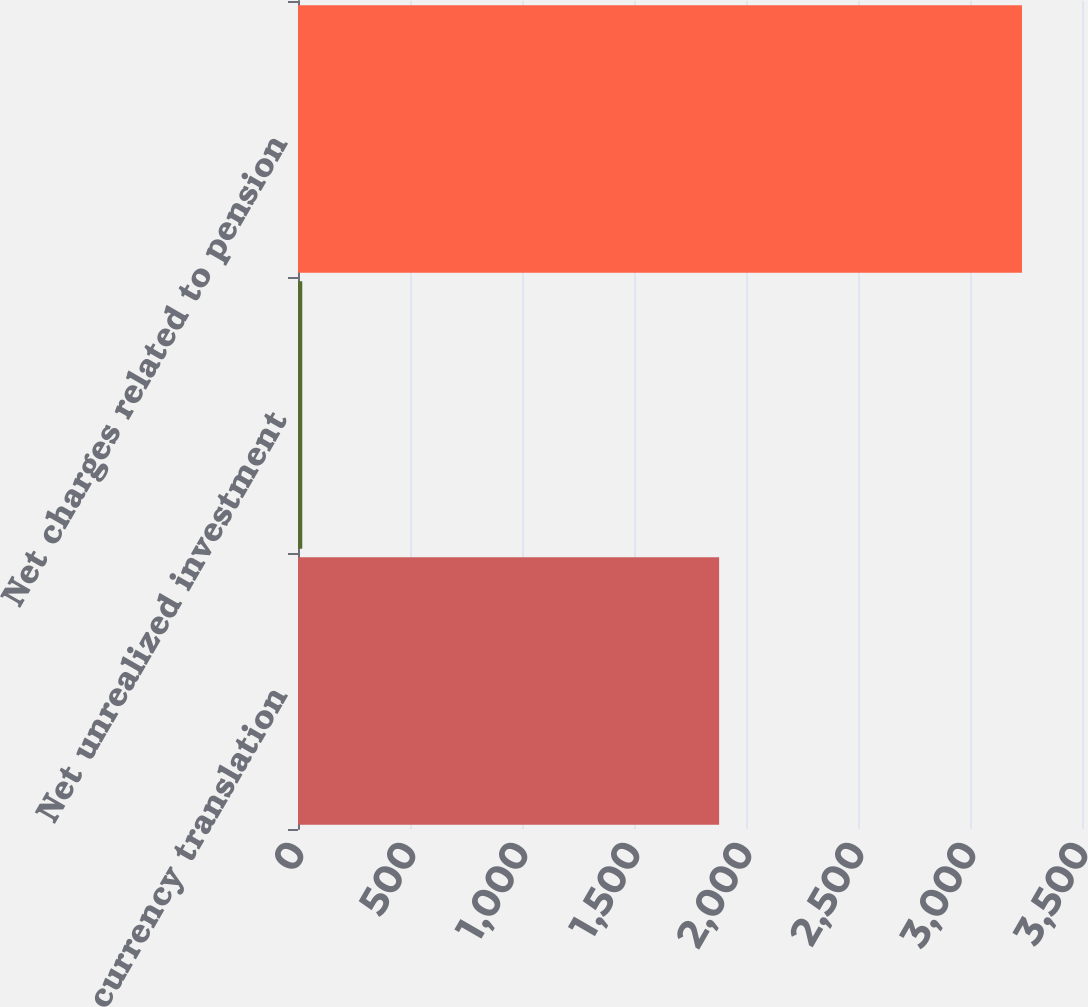Convert chart. <chart><loc_0><loc_0><loc_500><loc_500><bar_chart><fcel>Foreign currency translation<fcel>Net unrealized investment<fcel>Net charges related to pension<nl><fcel>1880<fcel>19<fcel>3232<nl></chart> 